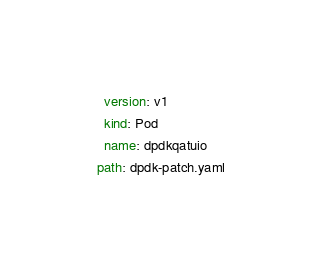Convert code to text. <code><loc_0><loc_0><loc_500><loc_500><_YAML_>    version: v1
    kind: Pod
    name: dpdkqatuio
  path: dpdk-patch.yaml
</code> 